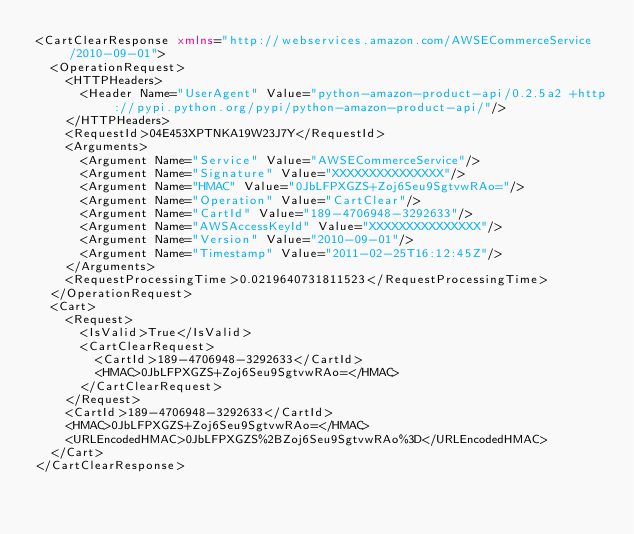Convert code to text. <code><loc_0><loc_0><loc_500><loc_500><_XML_><CartClearResponse xmlns="http://webservices.amazon.com/AWSECommerceService/2010-09-01">
  <OperationRequest>
    <HTTPHeaders>
      <Header Name="UserAgent" Value="python-amazon-product-api/0.2.5a2 +http://pypi.python.org/pypi/python-amazon-product-api/"/>
    </HTTPHeaders>
    <RequestId>04E453XPTNKA19W23J7Y</RequestId>
    <Arguments>
      <Argument Name="Service" Value="AWSECommerceService"/>
      <Argument Name="Signature" Value="XXXXXXXXXXXXXXX"/>
      <Argument Name="HMAC" Value="0JbLFPXGZS+Zoj6Seu9SgtvwRAo="/>
      <Argument Name="Operation" Value="CartClear"/>
      <Argument Name="CartId" Value="189-4706948-3292633"/>
      <Argument Name="AWSAccessKeyId" Value="XXXXXXXXXXXXXXX"/>
      <Argument Name="Version" Value="2010-09-01"/>
      <Argument Name="Timestamp" Value="2011-02-25T16:12:45Z"/>
    </Arguments>
    <RequestProcessingTime>0.0219640731811523</RequestProcessingTime>
  </OperationRequest>
  <Cart>
    <Request>
      <IsValid>True</IsValid>
      <CartClearRequest>
        <CartId>189-4706948-3292633</CartId>
        <HMAC>0JbLFPXGZS+Zoj6Seu9SgtvwRAo=</HMAC>
      </CartClearRequest>
    </Request>
    <CartId>189-4706948-3292633</CartId>
    <HMAC>0JbLFPXGZS+Zoj6Seu9SgtvwRAo=</HMAC>
    <URLEncodedHMAC>0JbLFPXGZS%2BZoj6Seu9SgtvwRAo%3D</URLEncodedHMAC>
  </Cart>
</CartClearResponse>
</code> 